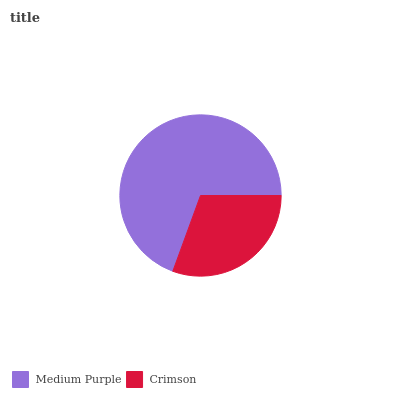Is Crimson the minimum?
Answer yes or no. Yes. Is Medium Purple the maximum?
Answer yes or no. Yes. Is Crimson the maximum?
Answer yes or no. No. Is Medium Purple greater than Crimson?
Answer yes or no. Yes. Is Crimson less than Medium Purple?
Answer yes or no. Yes. Is Crimson greater than Medium Purple?
Answer yes or no. No. Is Medium Purple less than Crimson?
Answer yes or no. No. Is Medium Purple the high median?
Answer yes or no. Yes. Is Crimson the low median?
Answer yes or no. Yes. Is Crimson the high median?
Answer yes or no. No. Is Medium Purple the low median?
Answer yes or no. No. 